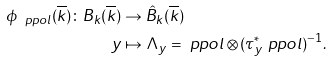Convert formula to latex. <formula><loc_0><loc_0><loc_500><loc_500>\phi _ { \ p p o l } ( \overline { k } ) \colon B _ { k } ( \overline { k } ) & \to \hat { B } _ { k } ( \overline { k } ) \\ y & \mapsto \Lambda _ { y } = \ p p o l \otimes ( \tau ^ { * } _ { y } \ p p o l ) ^ { - 1 } .</formula> 